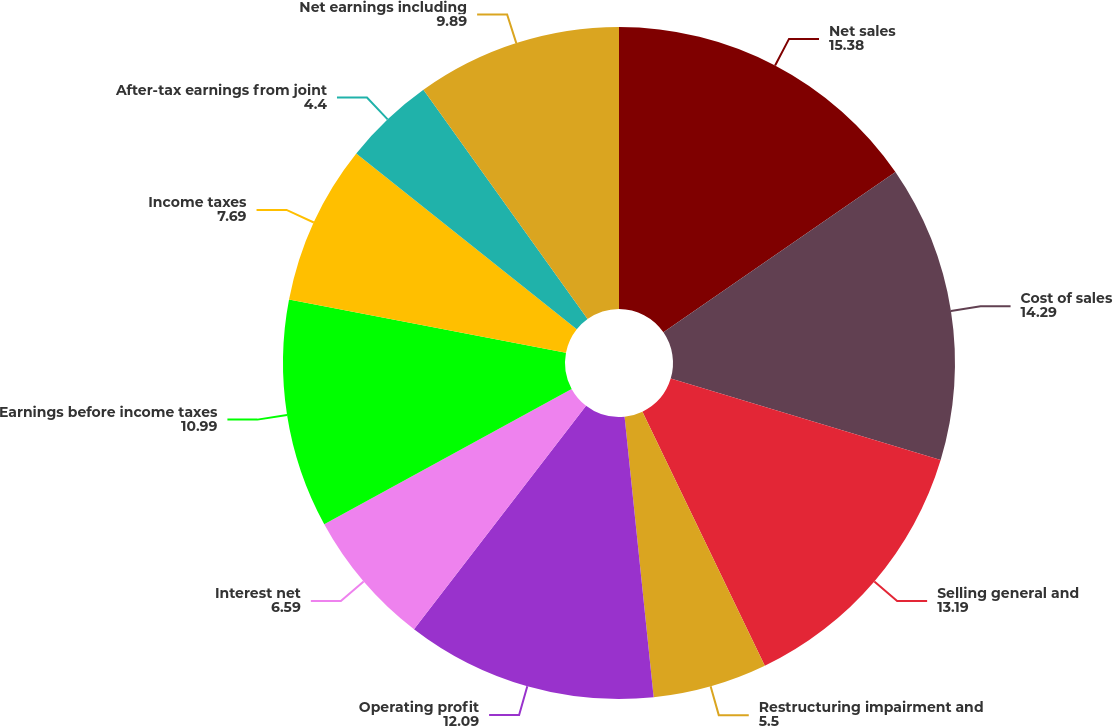Convert chart. <chart><loc_0><loc_0><loc_500><loc_500><pie_chart><fcel>Net sales<fcel>Cost of sales<fcel>Selling general and<fcel>Restructuring impairment and<fcel>Operating profit<fcel>Interest net<fcel>Earnings before income taxes<fcel>Income taxes<fcel>After-tax earnings from joint<fcel>Net earnings including<nl><fcel>15.38%<fcel>14.29%<fcel>13.19%<fcel>5.5%<fcel>12.09%<fcel>6.59%<fcel>10.99%<fcel>7.69%<fcel>4.4%<fcel>9.89%<nl></chart> 